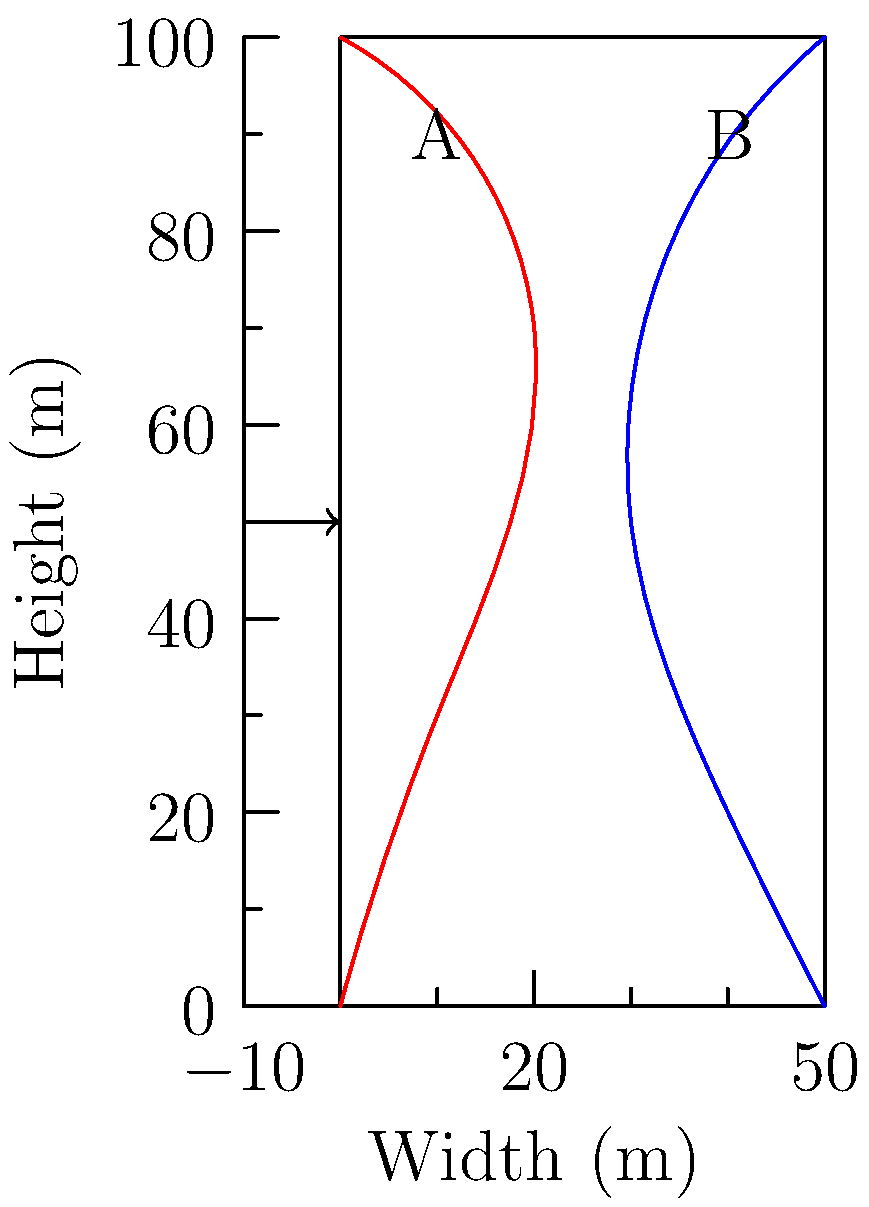In the diagram, two wind load distributions are shown for a tall building with different architectural features on its sides. Side A (red) has a convex profile, while side B (blue) has a concave profile. Which side is likely to experience higher wind loads near the top of the building, and how might this relate to the concept of stress distribution in the brain during pain perception? To answer this question, let's break it down step-by-step:

1. Wind load distribution:
   - Side A (red) shows a convex profile, with the wind load increasing more rapidly near the top.
   - Side B (blue) shows a concave profile, with the wind load increasing more gradually.

2. Comparison of wind loads:
   - Near the top of the building, the red curve (Side A) extends further from the building outline than the blue curve (Side B).
   - This indicates that Side A experiences higher wind loads near the top of the building.

3. Reasons for the difference:
   - The convex profile of Side A creates more surface area exposed to wind at higher elevations.
   - The concave profile of Side B allows for some wind deflection, reducing the load at higher elevations.

4. Relation to stress distribution in the brain during pain perception:
   - In neuroscience, stress distribution in the brain during pain perception can be analogous to force distribution in structures.
   - Just as architectural features affect wind load distribution, neuroanatomical features can influence how pain signals are processed and distributed in the brain.
   - The convex profile (Side A) causing higher loads at the top could be likened to how certain brain regions might experience heightened activity or "stress" during pain perception.
   - The concave profile (Side B) with more gradual load increase might represent brain regions with more distributed or modulated pain signal processing.

5. Implications for neuroscience research:
   - Understanding how different "shapes" or structures in the brain affect pain signal distribution could lead to insights into pain perception mechanisms.
   - This analogy might inspire new ways of visualizing or modeling pain signal propagation in the brain.
Answer: Side A experiences higher wind loads near the top, analogous to how certain brain regions might show heightened activity during pain perception. 